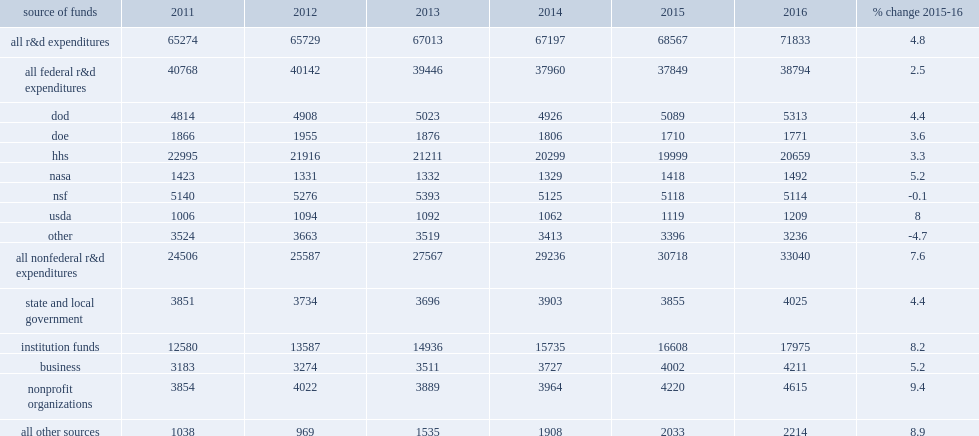In current dollars, how many percent did federally funded r&d at universities increase in fy 2016? 2.5. In current dollars, how many million dollars did federally funded r&d at universities increase in fy 2016? 38794.0. In fy 2011, how many percent of total r&d expenditures was federally funded expenditures? 0.624567. In fy 2016, how many percent of total r&d expenditures was federally funded expenditures? 0.540058. All of the nonfederal funding sources showed increases from fy 2015 to fy 2016, how many percent in total rising in fy 2016? 7.6. All of the nonfederal funding sources showed increases from fy 2015 to fy 2016, how many million dollars in total rising to in fy 2016? 33040.0. Which source of funds did expenditures funded had the largest increase? Nonprofit organizations. 